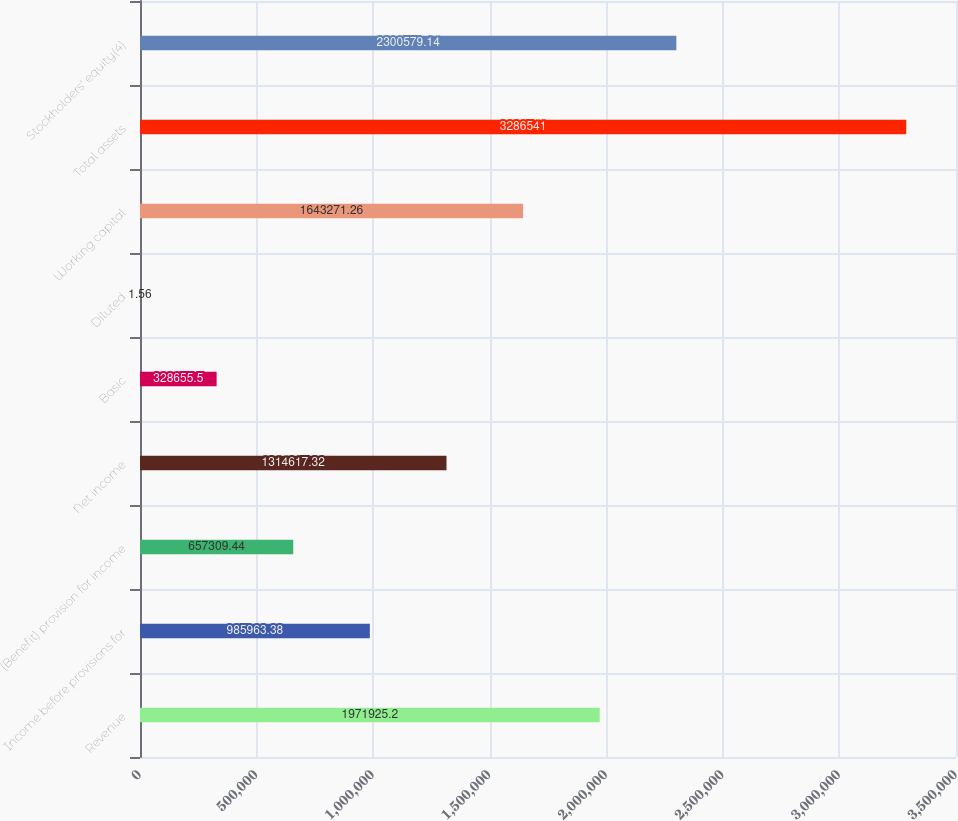<chart> <loc_0><loc_0><loc_500><loc_500><bar_chart><fcel>Revenue<fcel>Income before provisions for<fcel>(Benefit) provision for income<fcel>Net income<fcel>Basic<fcel>Diluted<fcel>Working capital<fcel>Total assets<fcel>Stockholders' equity(4)<nl><fcel>1.97193e+06<fcel>985963<fcel>657309<fcel>1.31462e+06<fcel>328656<fcel>1.56<fcel>1.64327e+06<fcel>3.28654e+06<fcel>2.30058e+06<nl></chart> 